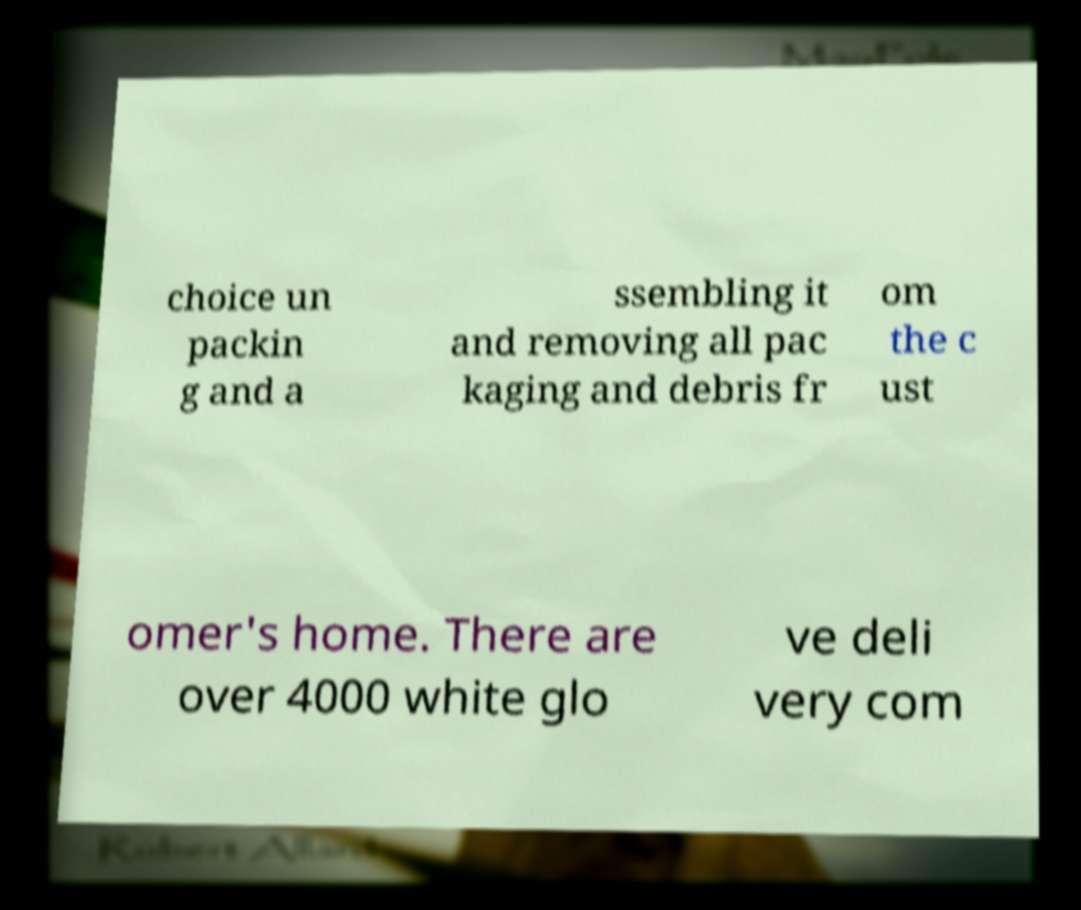Could you extract and type out the text from this image? choice un packin g and a ssembling it and removing all pac kaging and debris fr om the c ust omer's home. There are over 4000 white glo ve deli very com 